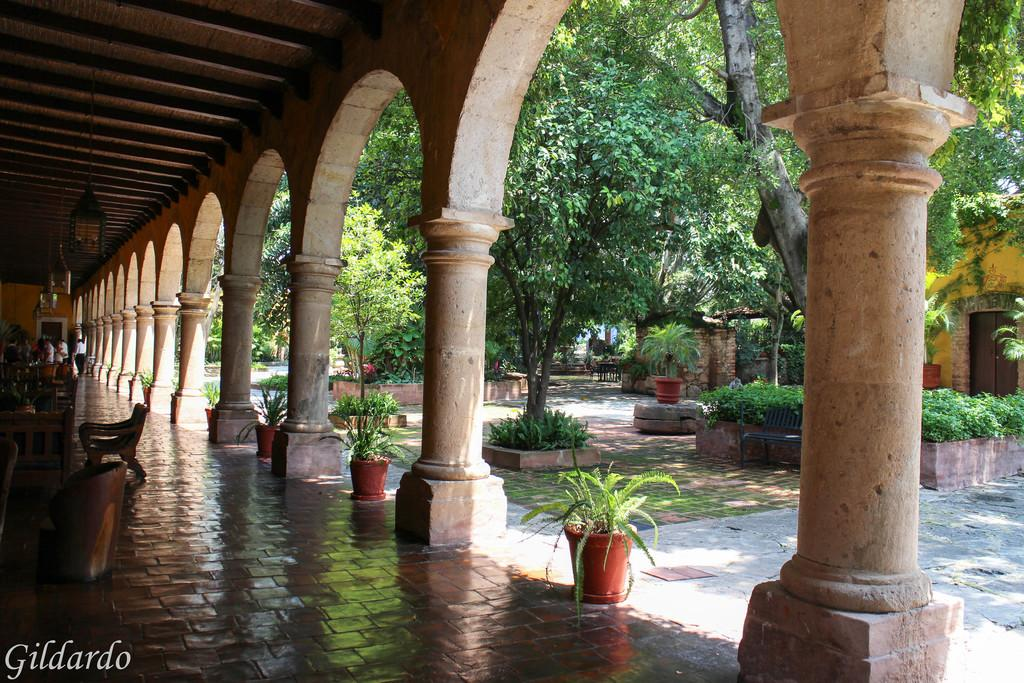What is the surface on which objects are placed in the image? There is a floor in the image. What type of furniture can be seen on the floor? There are chairs on the floor. What architectural elements are present in the image? There are columns in the image. What type of vegetation is visible on the right side of the image? There are green color trees on the right side of the image. How many pairs of shoes are visible on the floor in the image? There is no mention of shoes in the image, so we cannot determine the number of pairs visible. 